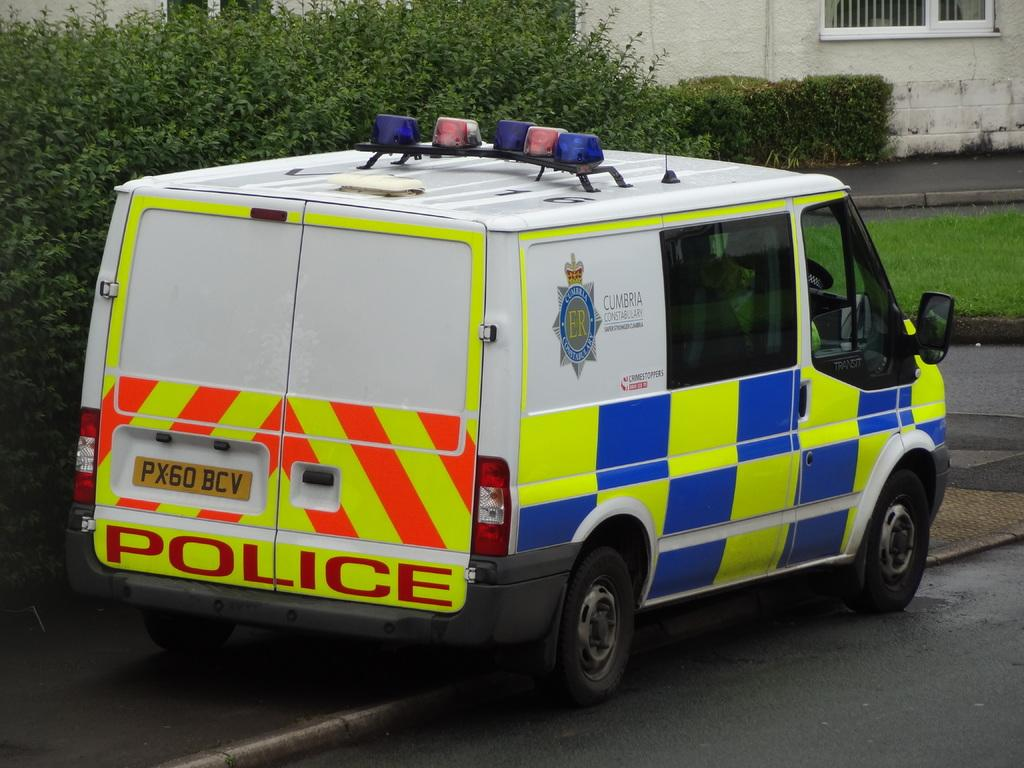Provide a one-sentence caption for the provided image. A police mini bus with a license plate  number: PX60 BCV. 